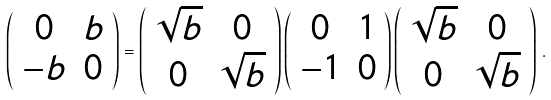<formula> <loc_0><loc_0><loc_500><loc_500>\left ( \begin{array} { c c } 0 & b \\ - b & 0 \end{array} \right ) = \left ( \begin{array} { c c } \sqrt { b } & 0 \\ 0 & \sqrt { b } \end{array} \right ) \left ( \begin{array} { c c } 0 & 1 \\ - 1 & 0 \end{array} \right ) \left ( \begin{array} { c c } \sqrt { b } & 0 \\ 0 & \sqrt { b } \end{array} \right ) \, .</formula> 